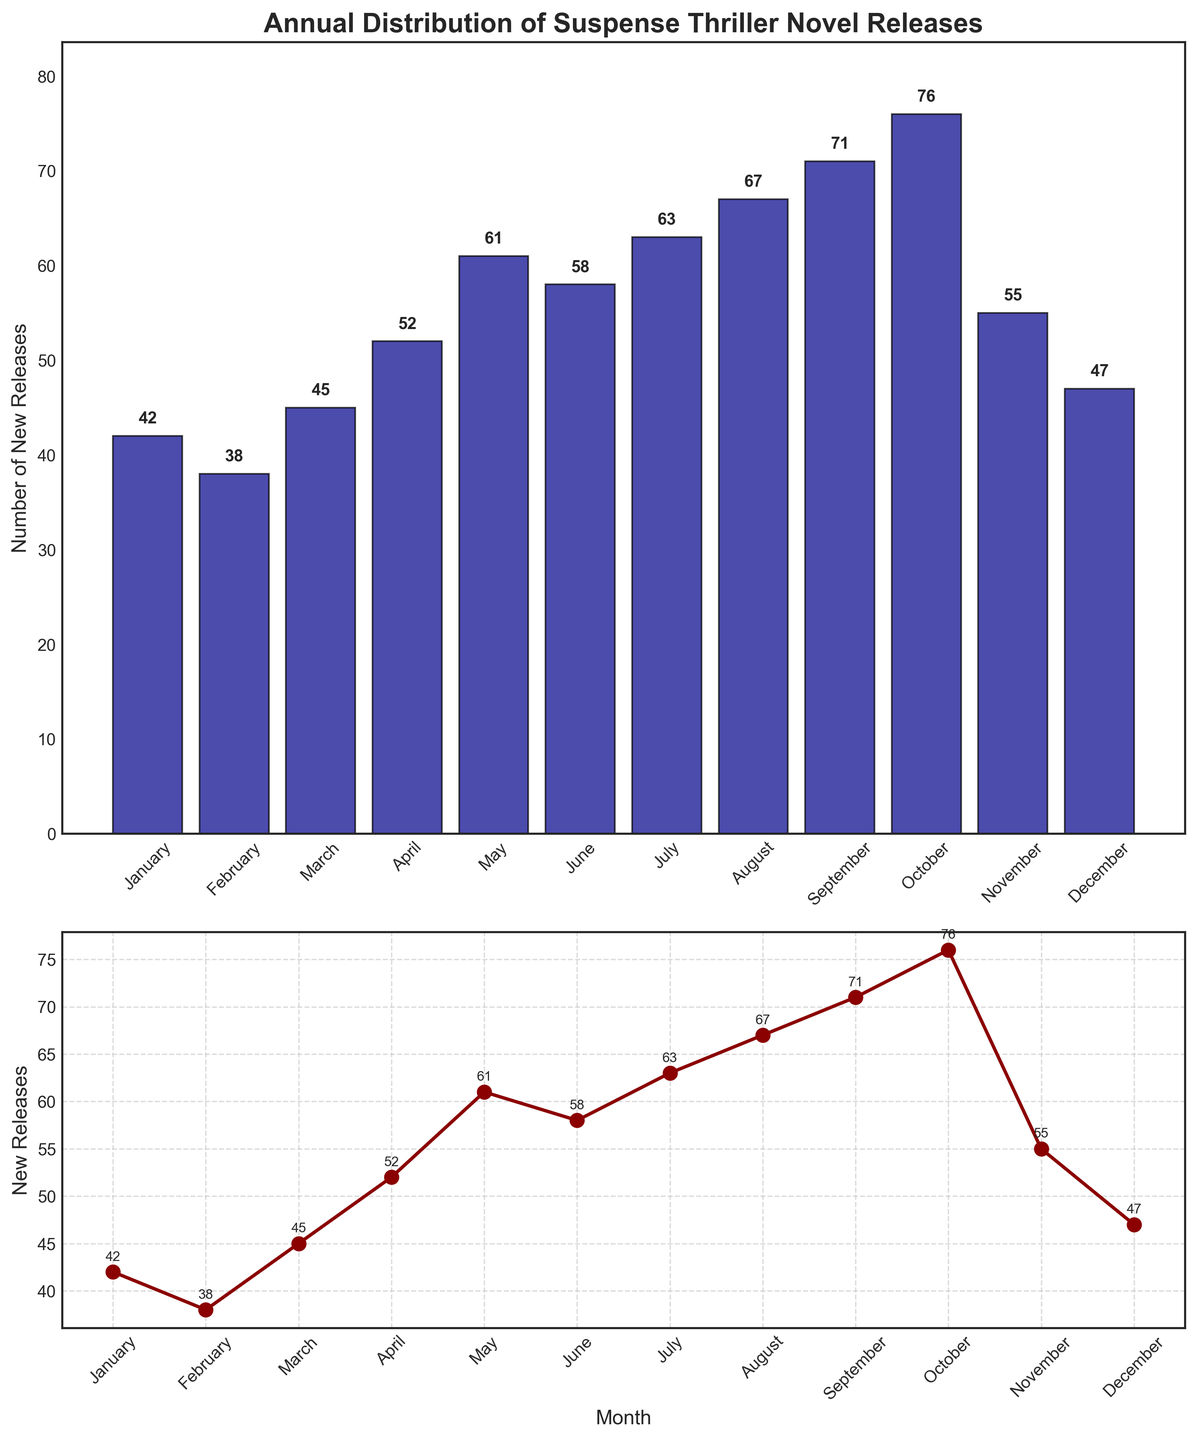What is the title of the figure? The title of the figure is typically placed at the top of the plot and it provides an overview of what the figure represents. The title of this figure is "Annual Distribution of Suspense Thriller Novel Releases".
Answer: Annual Distribution of Suspense Thriller Novel Releases Which month had the highest number of new suspense thriller releases? To find this, look at the plot and identify the month with the tallest bar in the bar plot or the highest point in the line plot. October has the highest number of new releases.
Answer: October How many new suspense thriller releases were there in May and June combined? To find the combined releases for May and June, add the number of releases in May (61) to the number of releases in June (58). 61 + 58 = 119.
Answer: 119 What is the general trend in the number of new releases from January to December? To determine the trend, observe the bar and line plots. Both plots indicate an overall increase in the number of new releases as the year progresses, with some minor fluctuations. The trend is upward-moving.
Answer: Upward-moving Which month had fewer releases: February or November? To compare February and November, look at the bar plot or line plot. February had 38 releases, whereas November had 55. February had fewer releases.
Answer: February What is the difference in the number of new releases between the peak month and the month with the lowest releases? The peak month is October with 76 releases and the lowest month is February with 38 releases. The difference is 76 - 38 = 38.
Answer: 38 Does the line plot provide any additional insights compared to the bar plot? The line plot provides a smoother visualization of the monthly trend and highlights the increase or decrease more clearly between consecutive months. It shows the upward trend and fluctuations in a connected manner.
Answer: Smoother visualization of trends What is the average number of new suspense thriller releases per month? To calculate the average, sum all the monthly releases and divide by the number of months. The total is 675, and there are 12 months. 675 ÷ 12 = 56.25.
Answer: 56.25 Between July and August, did the number of releases increase or decrease? To determine the change between these months, compare the bar heights or data points. July had 63 releases, and August had 67. There was an increase.
Answer: Increase 